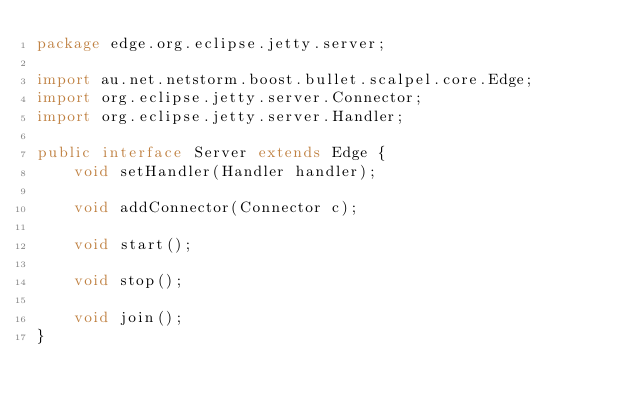<code> <loc_0><loc_0><loc_500><loc_500><_Java_>package edge.org.eclipse.jetty.server;

import au.net.netstorm.boost.bullet.scalpel.core.Edge;
import org.eclipse.jetty.server.Connector;
import org.eclipse.jetty.server.Handler;

public interface Server extends Edge {
    void setHandler(Handler handler);

    void addConnector(Connector c);

    void start();

    void stop();

    void join();
}
</code> 